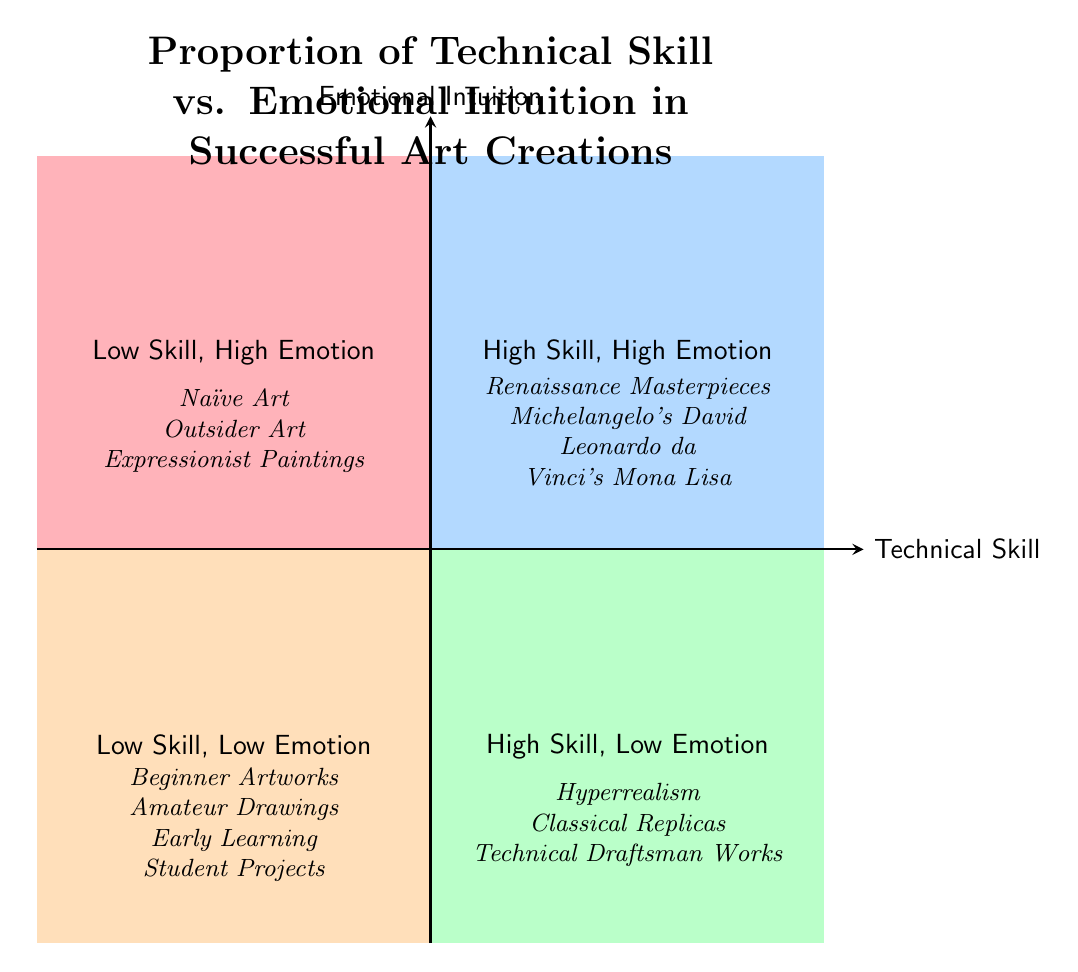What's in the "High Skill, High Emotion" quadrant? This quadrant contains examples of art that possess both technical skill and emotional depth. Looking at the quadrant, the specific examples listed are Renaissance Masterpieces, Michelangelo's David, and Leonardo da Vinci's Mona Lisa.
Answer: Renaissance Masterpieces, Michelangelo's David, Leonardo da Vinci's Mona Lisa How many quadrants are there in the diagram? The diagram is divided into four quadrants, each representing a different relationship between technical skill and emotional intuition.
Answer: 4 Which quadrant features "Hyperrealism"? "Hyperrealism" is located in the "High Skill, Low Emotion" quadrant, as it showcases strong technical skills but lacks emotional depth.
Answer: High Skill, Low Emotion What is the emotional quality of artworks in the "Low Skill, High Emotion" quadrant? This quadrant is characterized by a high emotional quality in artworks, demonstrating raw emotional expression, often created without bound by traditional techniques.
Answer: High Which quadrant includes "Outsider Art"? "Outsider Art" is found in the "Low Skill, High Emotion" quadrant. This artwork emphasizes emotional expression over technical skill.
Answer: Low Skill, High Emotion What type of artworks can be found in the "Low Skill, Low Emotion" quadrant? This quadrant features artworks often created by novices or students and is notably characterized by having both limited technical skill and emotional depth. Examples include Beginner Artworks, Amateur Drawings, and Early Learning Student Projects.
Answer: Beginner Artworks, Amateur Drawings, Early Learning Student Projects Is "Technical Draftsman Works" associated with high emotional intuition? No, "Technical Draftsman Works" falls within the "High Skill, Low Emotion" quadrant. This indicates that it has a high level of technical skill but lacks emotional intuition.
Answer: No What category does "Expressionist Paintings" fall into? "Expressionist Paintings" belong to the "Low Skill, High Emotion" quadrant, as they prioritize emotional expression over technical correctness.
Answer: Low Skill, High Emotion 